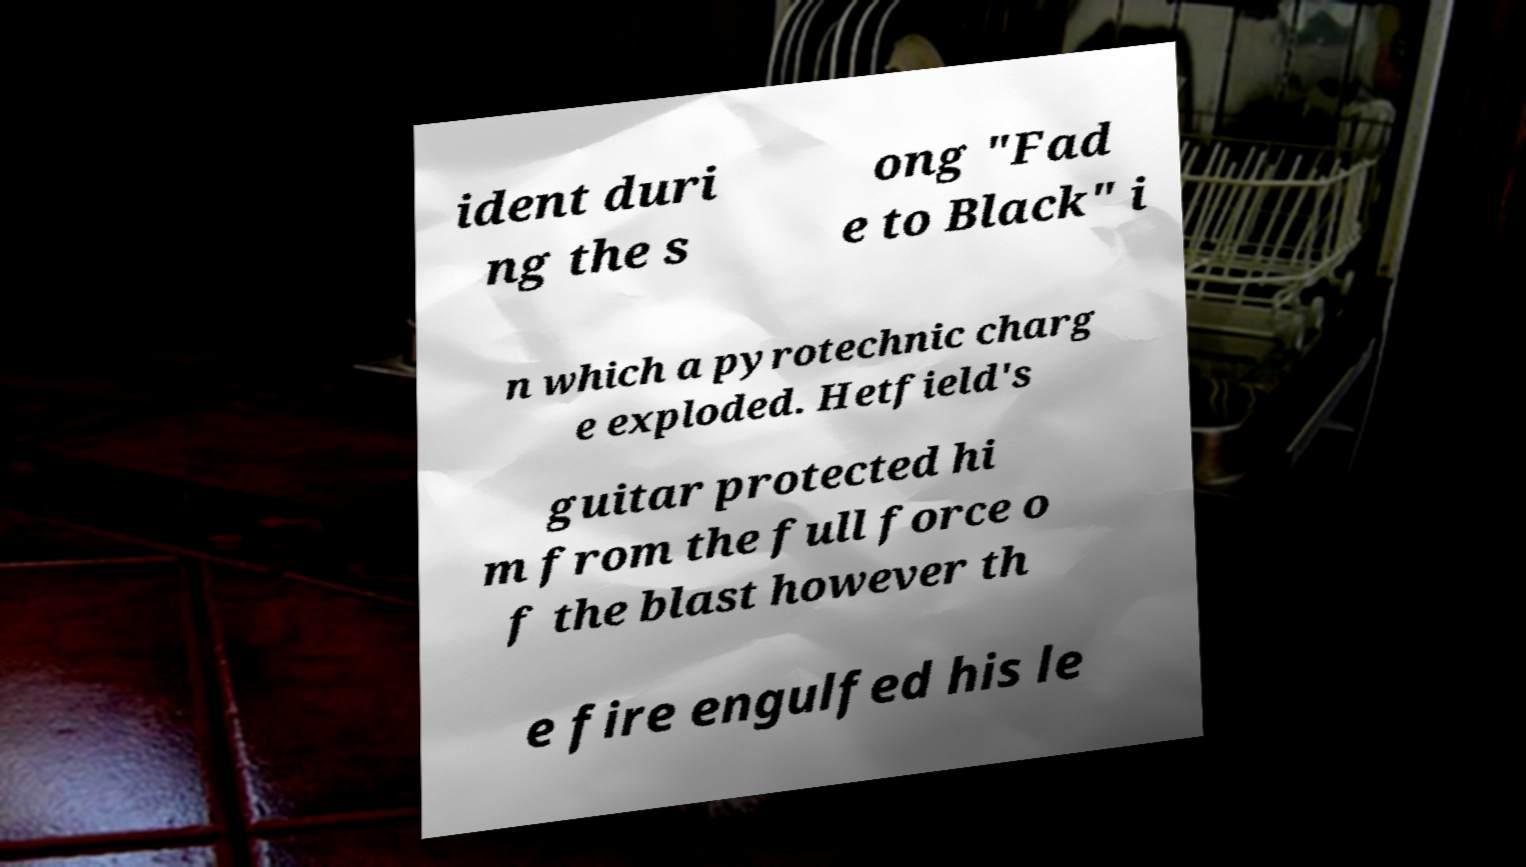Please read and relay the text visible in this image. What does it say? ident duri ng the s ong "Fad e to Black" i n which a pyrotechnic charg e exploded. Hetfield's guitar protected hi m from the full force o f the blast however th e fire engulfed his le 